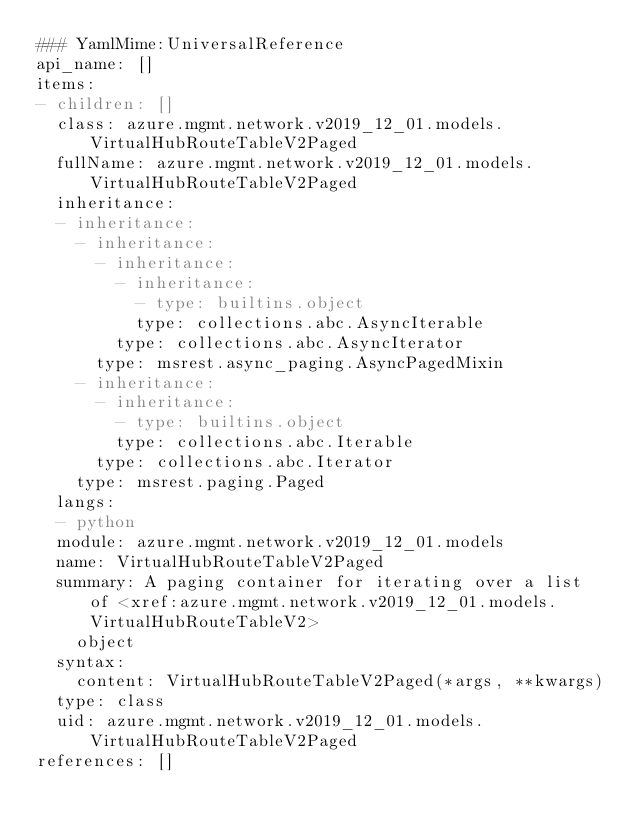<code> <loc_0><loc_0><loc_500><loc_500><_YAML_>### YamlMime:UniversalReference
api_name: []
items:
- children: []
  class: azure.mgmt.network.v2019_12_01.models.VirtualHubRouteTableV2Paged
  fullName: azure.mgmt.network.v2019_12_01.models.VirtualHubRouteTableV2Paged
  inheritance:
  - inheritance:
    - inheritance:
      - inheritance:
        - inheritance:
          - type: builtins.object
          type: collections.abc.AsyncIterable
        type: collections.abc.AsyncIterator
      type: msrest.async_paging.AsyncPagedMixin
    - inheritance:
      - inheritance:
        - type: builtins.object
        type: collections.abc.Iterable
      type: collections.abc.Iterator
    type: msrest.paging.Paged
  langs:
  - python
  module: azure.mgmt.network.v2019_12_01.models
  name: VirtualHubRouteTableV2Paged
  summary: A paging container for iterating over a list of <xref:azure.mgmt.network.v2019_12_01.models.VirtualHubRouteTableV2>
    object
  syntax:
    content: VirtualHubRouteTableV2Paged(*args, **kwargs)
  type: class
  uid: azure.mgmt.network.v2019_12_01.models.VirtualHubRouteTableV2Paged
references: []
</code> 